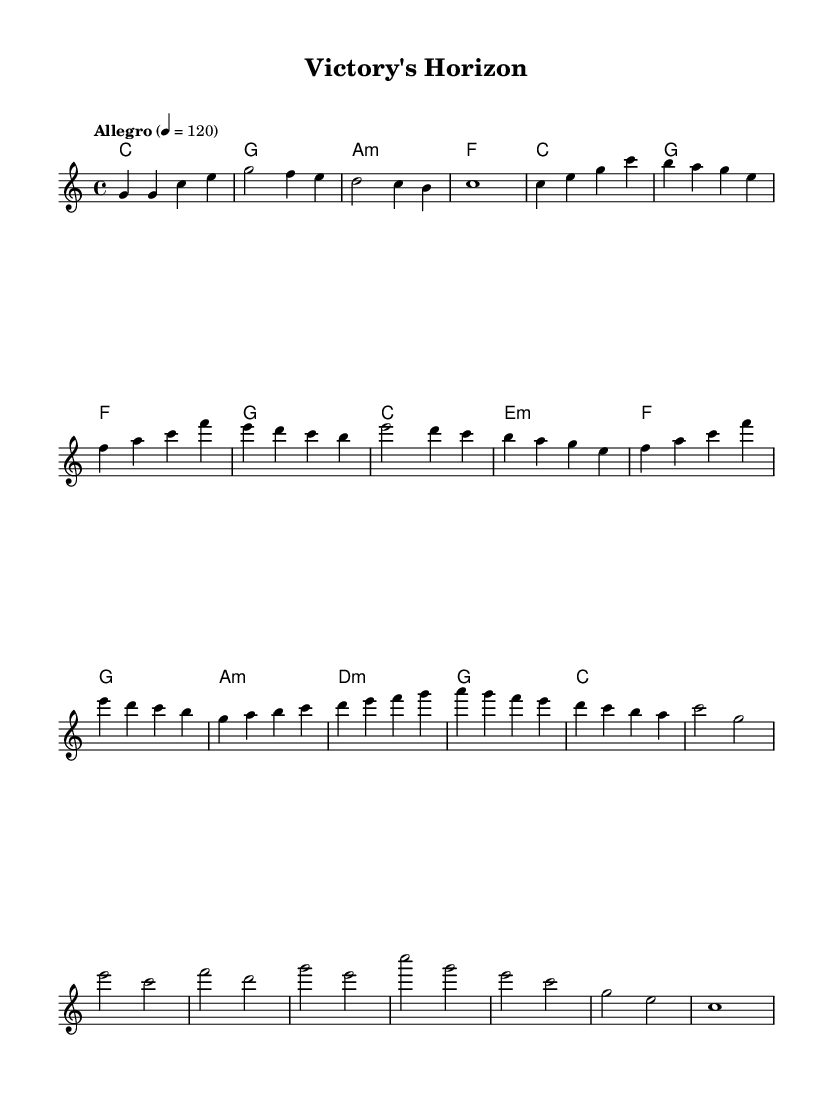What is the key signature of this music? The key signature is C major, which has no sharps or flats.
Answer: C major What is the time signature of this score? The time signature is indicated at the beginning of the music and shows a 4/4 meter, meaning there are four beats in each measure.
Answer: 4/4 What is the tempo marking of this piece? The tempo marking is provided at the top of the score and specifies "Allegro," which signifies a fast tempo, along with a metronome indication of 120 beats per minute.
Answer: Allegro, 120 How many distinct themes are present in the music? By analyzing the structure, we can see two main themes (A and B) along with a bridge and a climax. This suggests a total of four identifiable sections or themes.
Answer: 4 What chord follows the first measure of the main theme? The first measure of the main theme has a C major chord, which serves as the base of the melody. This can be confirmed by looking at the harmony line that corresponds to it.
Answer: C What is the climax section primarily composed of in this piece? The climax section consists of a series of high pitches starting from a C in the second octave down to an E, representing the elevation of intensity in the call and response of the melody.
Answer: C, G, E How does the bridge section relate to the rest of the piece? The bridge section serves as a transition, smoothly connecting the main themes by progressing through a rising sequence of notes, which heightens the tension before reaching the climax.
Answer: Transition 